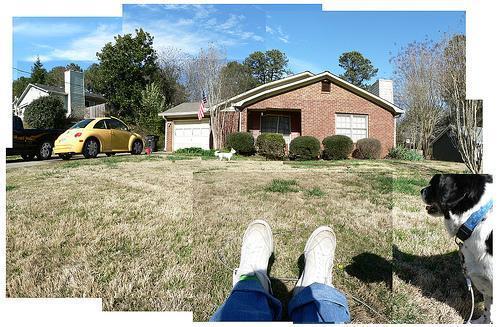How many cars are in the driveway?
Give a very brief answer. 2. 